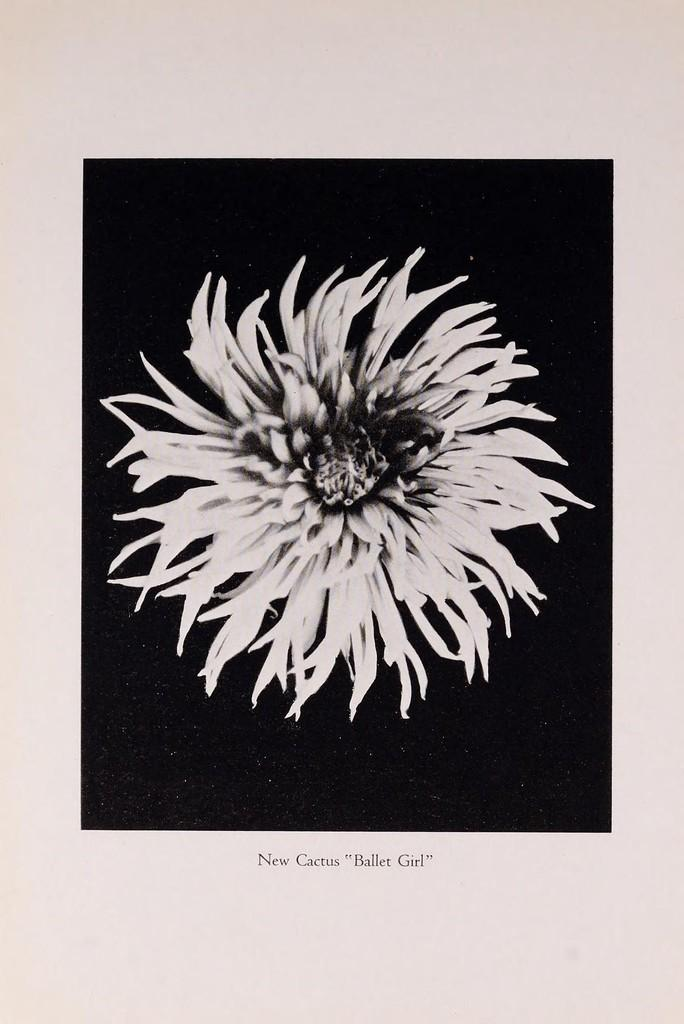What is present on the paper in the image? The paper has a flower on it. What else can be seen on the paper? There is text on the paper. What is the color of the background in the image? The background of the image is black. What type of potato is being used as a spy in the image? There is no potato or reference to spying in the image; it features a paper with a flower and text on it. 